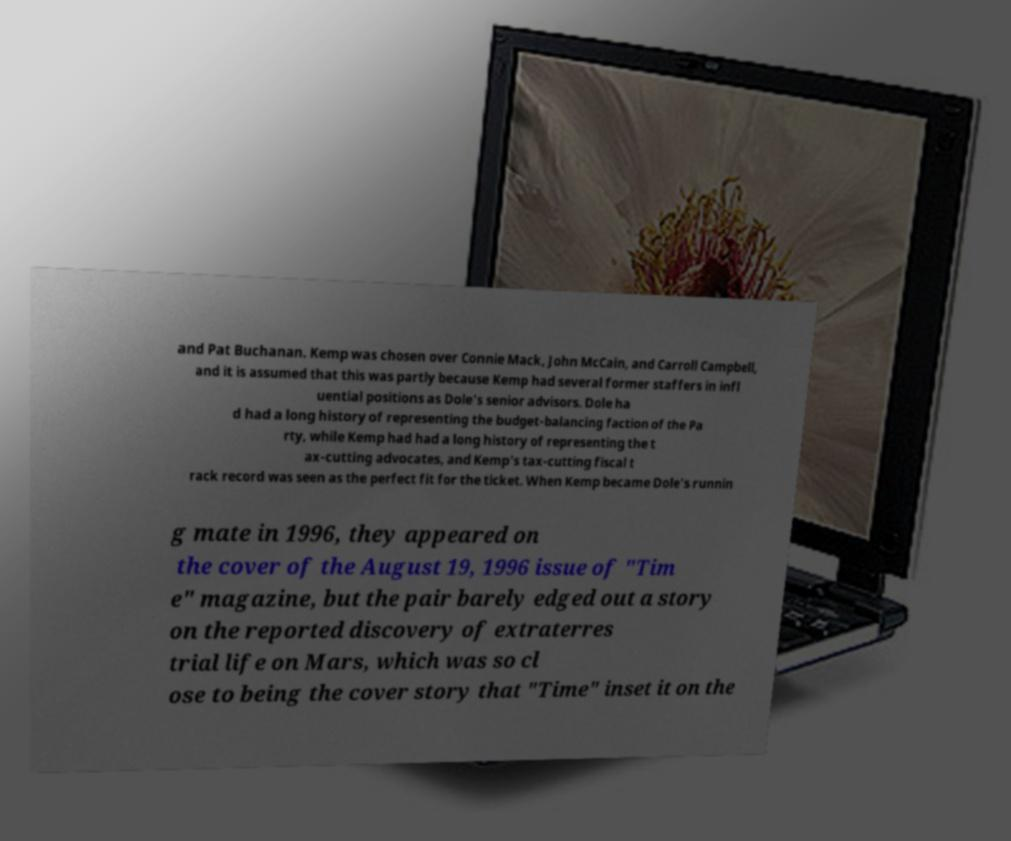There's text embedded in this image that I need extracted. Can you transcribe it verbatim? and Pat Buchanan. Kemp was chosen over Connie Mack, John McCain, and Carroll Campbell, and it is assumed that this was partly because Kemp had several former staffers in infl uential positions as Dole's senior advisors. Dole ha d had a long history of representing the budget-balancing faction of the Pa rty, while Kemp had had a long history of representing the t ax-cutting advocates, and Kemp's tax-cutting fiscal t rack record was seen as the perfect fit for the ticket. When Kemp became Dole's runnin g mate in 1996, they appeared on the cover of the August 19, 1996 issue of "Tim e" magazine, but the pair barely edged out a story on the reported discovery of extraterres trial life on Mars, which was so cl ose to being the cover story that "Time" inset it on the 